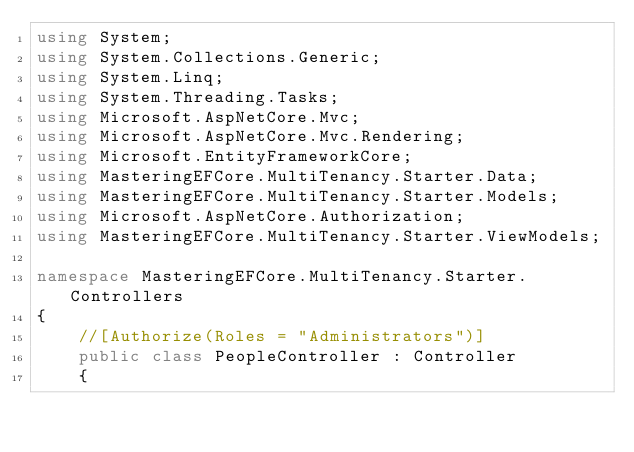<code> <loc_0><loc_0><loc_500><loc_500><_C#_>using System;
using System.Collections.Generic;
using System.Linq;
using System.Threading.Tasks;
using Microsoft.AspNetCore.Mvc;
using Microsoft.AspNetCore.Mvc.Rendering;
using Microsoft.EntityFrameworkCore;
using MasteringEFCore.MultiTenancy.Starter.Data;
using MasteringEFCore.MultiTenancy.Starter.Models;
using Microsoft.AspNetCore.Authorization;
using MasteringEFCore.MultiTenancy.Starter.ViewModels;

namespace MasteringEFCore.MultiTenancy.Starter.Controllers
{
    //[Authorize(Roles = "Administrators")]
    public class PeopleController : Controller
    {</code> 